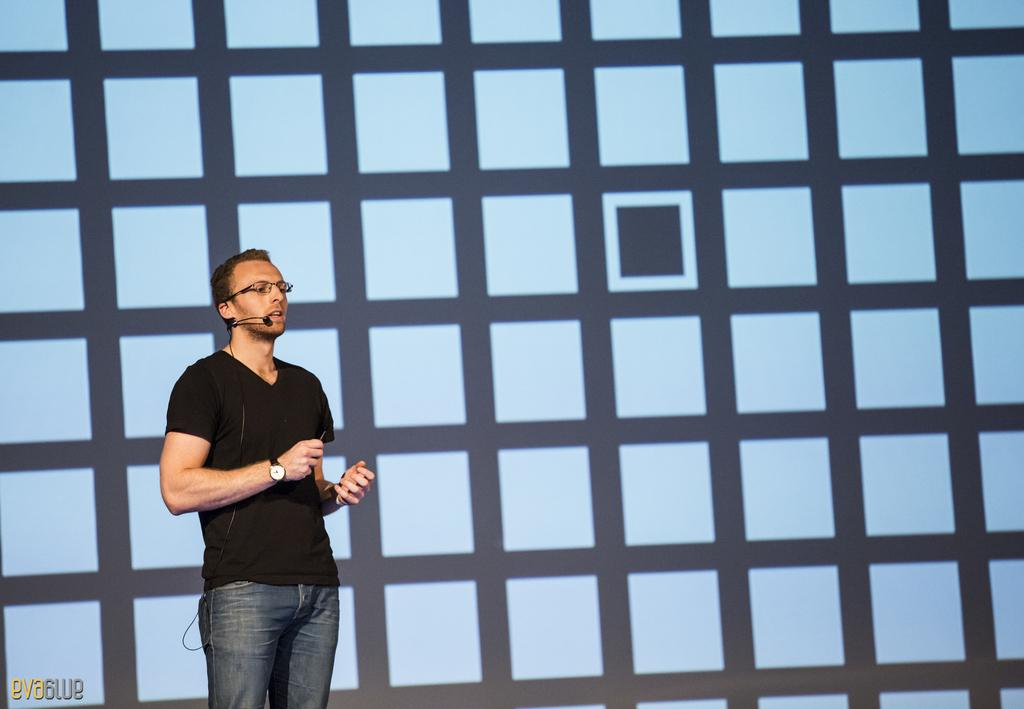What is the main subject of the image? There is a person standing in the image. What is the person's position in relation to the ground? The person is standing on the ground. What can be seen in the background of the image? There is a wall in the background of the image. How many pears are being used in the chess game in the image? There is no chess game or pear present in the image. 